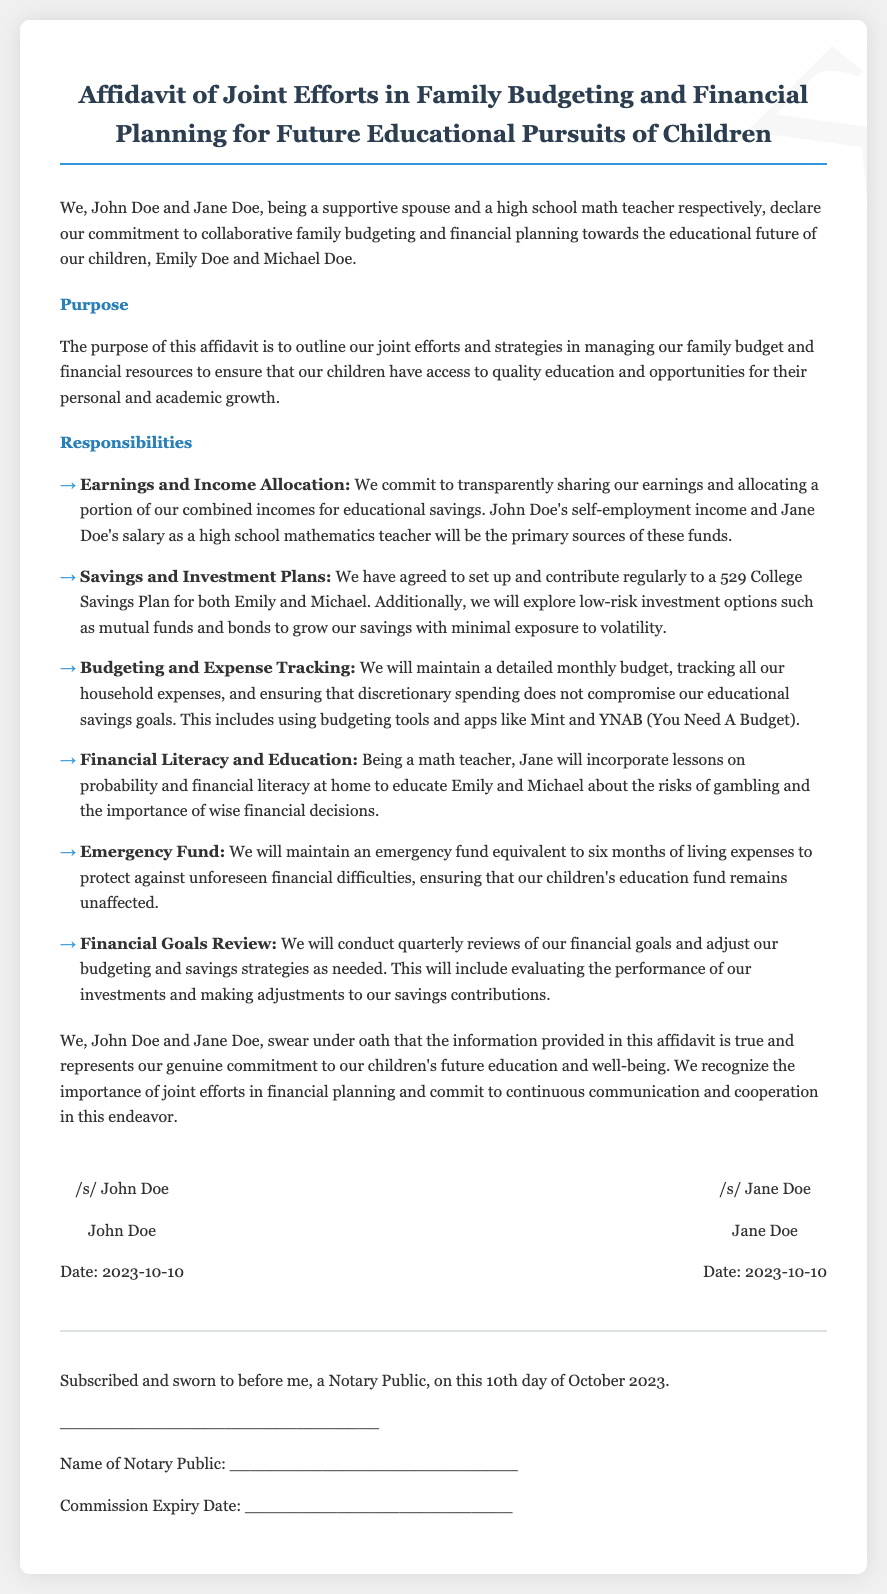What is the title of the document? The title of the document is prominently displayed at the top.
Answer: Affidavit of Joint Efforts in Family Budgeting and Financial Planning for Future Educational Pursuits of Children Who are the parties involved in the affidavit? The document mentions the names of both parties at the beginning.
Answer: John Doe and Jane Doe What is the date of the signatures? The signatures section notes the date when the affidavit was signed.
Answer: 2023-10-10 What type of savings plan is mentioned? The document specifies the kind of savings plan they have committed to.
Answer: 529 College Savings Plan How often will they review their financial goals? The document outlines their strategy for financial goal reviews.
Answer: Quarterly What is one of the budgeting tools mentioned? The document lists some budgeting tools they plan to use for tracking expenses.
Answer: Mint What is the purpose of this affidavit? The purpose is described in a section dedicated to summarizing the document's intent.
Answer: To outline joint efforts and strategies in managing the family budget and financial resources How long will the emergency fund cover? The document states the duration of the emergency fund they intend to maintain.
Answer: Six months of living expenses What will Jane teach Emily and Michael at home? The document mentions a specific subject that Jane will incorporate into lessons at home.
Answer: Probability and financial literacy 